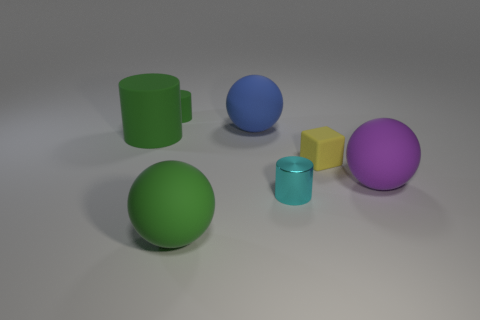Subtract all cyan cylinders. How many cylinders are left? 2 Subtract all tiny shiny cylinders. How many cylinders are left? 2 Add 3 tiny green things. How many tiny green things exist? 4 Add 3 big purple objects. How many objects exist? 10 Subtract 2 green cylinders. How many objects are left? 5 Subtract all spheres. How many objects are left? 4 Subtract 1 blocks. How many blocks are left? 0 Subtract all purple cylinders. Subtract all red cubes. How many cylinders are left? 3 Subtract all cyan cylinders. How many red blocks are left? 0 Subtract all metal objects. Subtract all matte things. How many objects are left? 0 